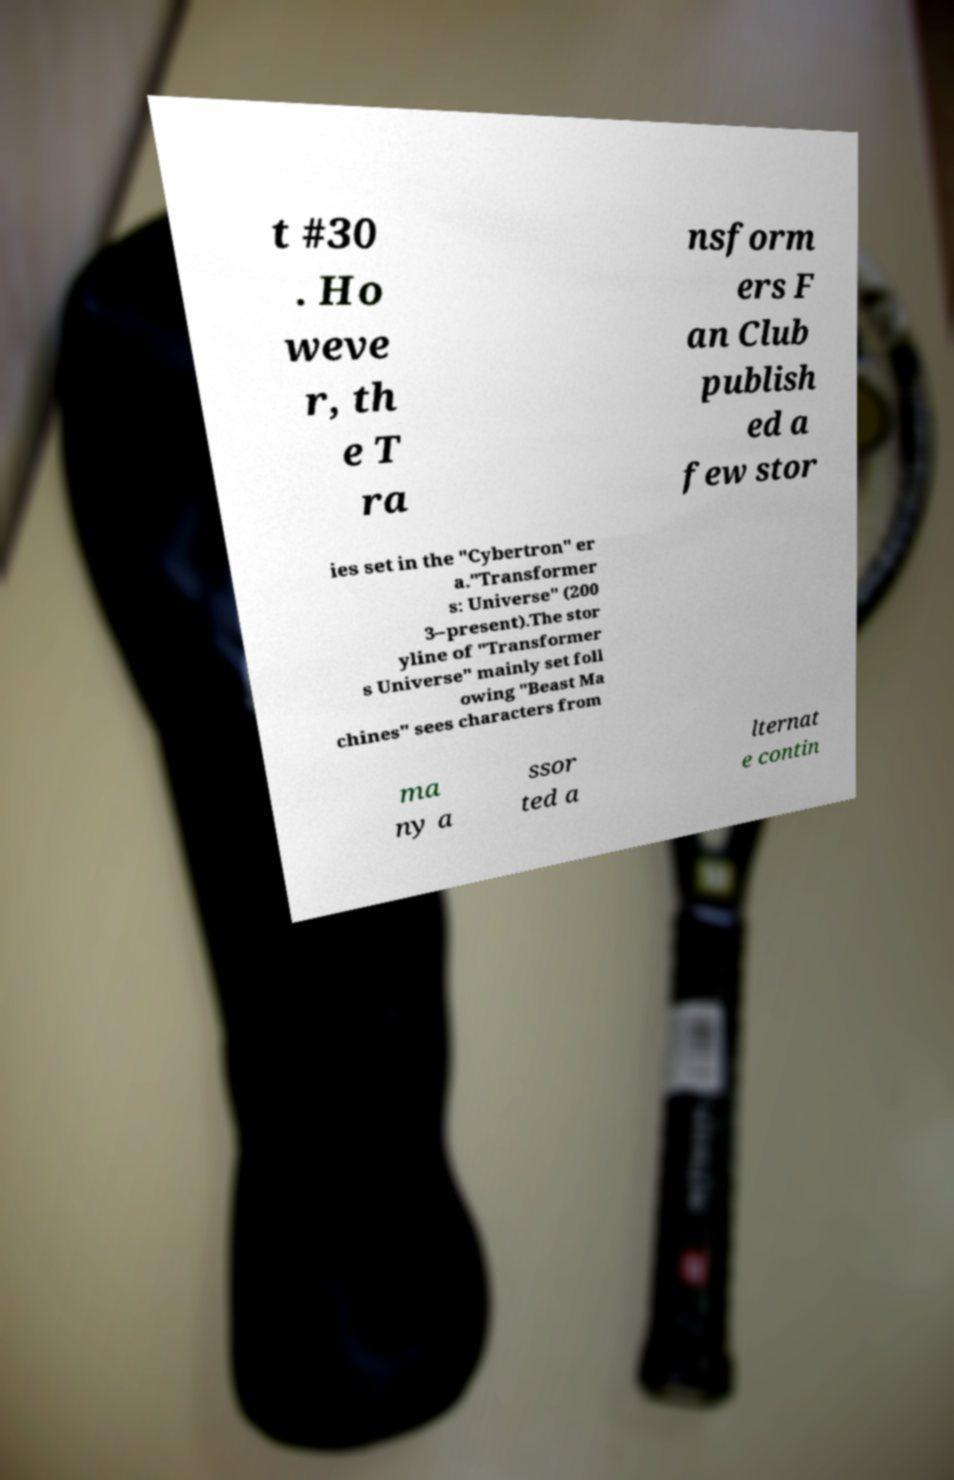What messages or text are displayed in this image? I need them in a readable, typed format. t #30 . Ho weve r, th e T ra nsform ers F an Club publish ed a few stor ies set in the "Cybertron" er a."Transformer s: Universe" (200 3–present).The stor yline of "Transformer s Universe" mainly set foll owing "Beast Ma chines" sees characters from ma ny a ssor ted a lternat e contin 